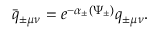Convert formula to latex. <formula><loc_0><loc_0><loc_500><loc_500>\bar { q } _ { \pm \mu \nu } = e ^ { - \alpha _ { \pm } ( \Psi _ { \pm } ) } q _ { \pm \mu \nu } .</formula> 